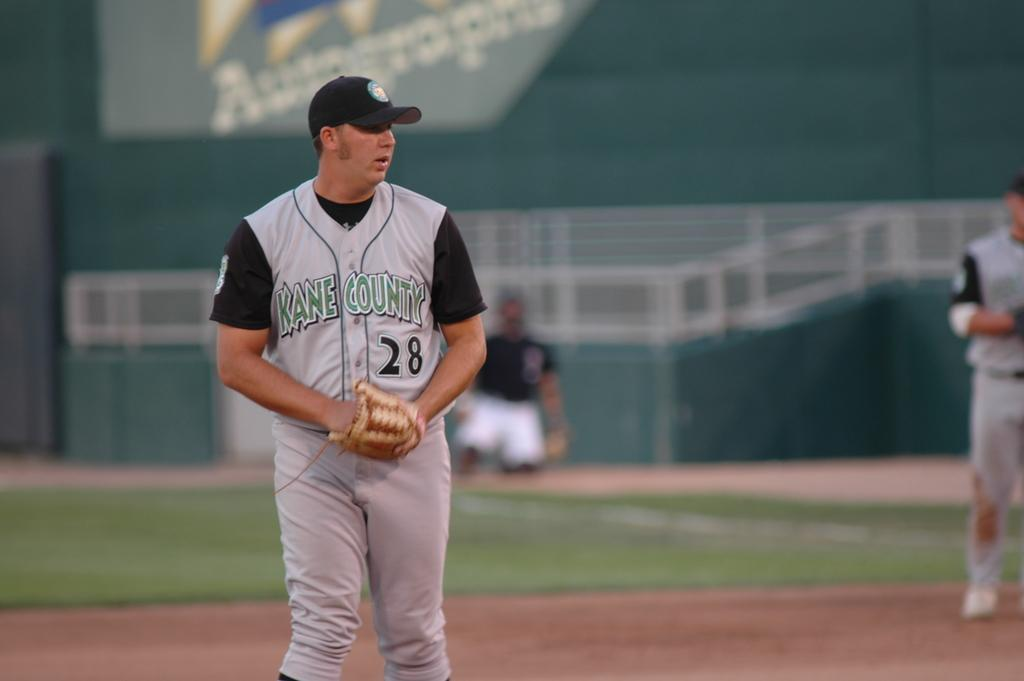<image>
Give a short and clear explanation of the subsequent image. Baseball player with a jersey that says Kane County. 